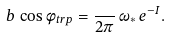<formula> <loc_0><loc_0><loc_500><loc_500>b \, \cos \phi _ { t r p } = \frac { } { 2 \pi } \, \omega _ { \ast } \, e ^ { - I } .</formula> 